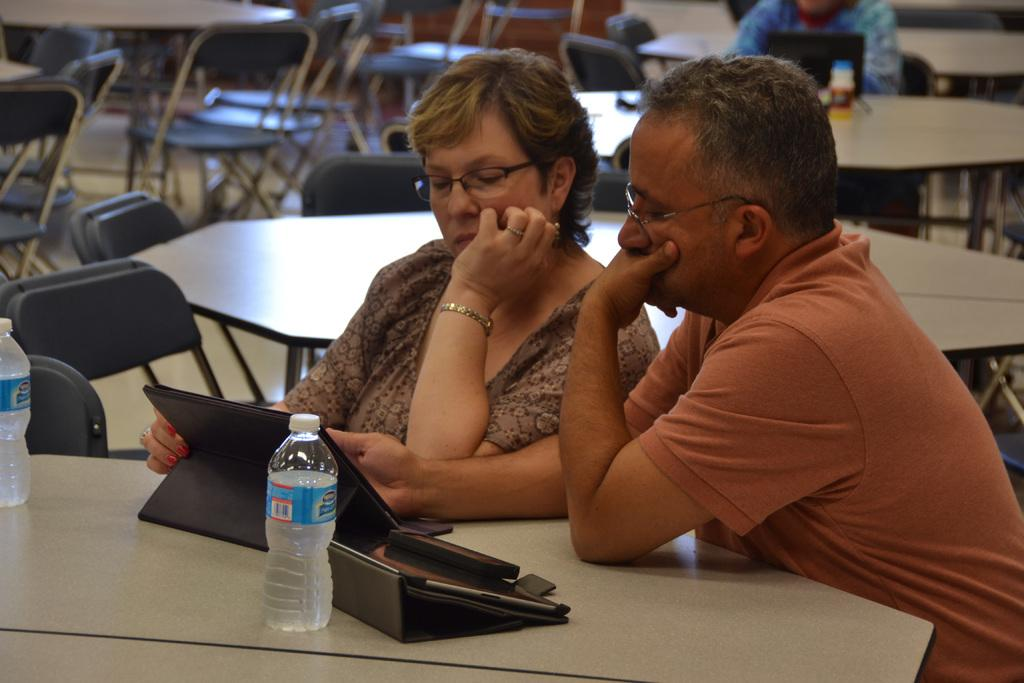How many people are in the image? There is a man and a woman in the image. What are the man and woman doing in the image? The man and woman are sitting at a table. What might the man and woman be focused on in the image? There is something in front of them that they are watching. How many stars can be seen smashing through the window in the image? There are no stars or windows present in the image, so this scenario cannot be observed. 